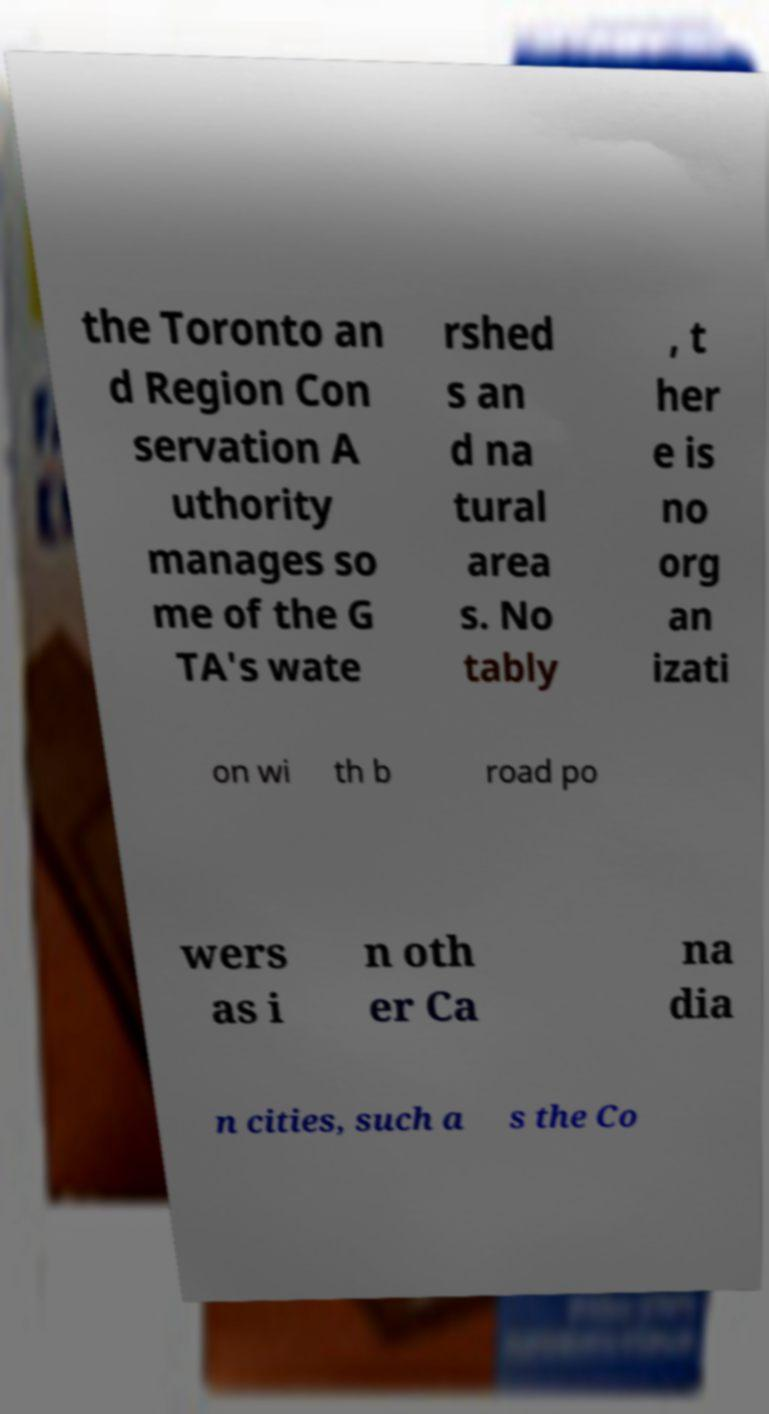Please read and relay the text visible in this image. What does it say? the Toronto an d Region Con servation A uthority manages so me of the G TA's wate rshed s an d na tural area s. No tably , t her e is no org an izati on wi th b road po wers as i n oth er Ca na dia n cities, such a s the Co 